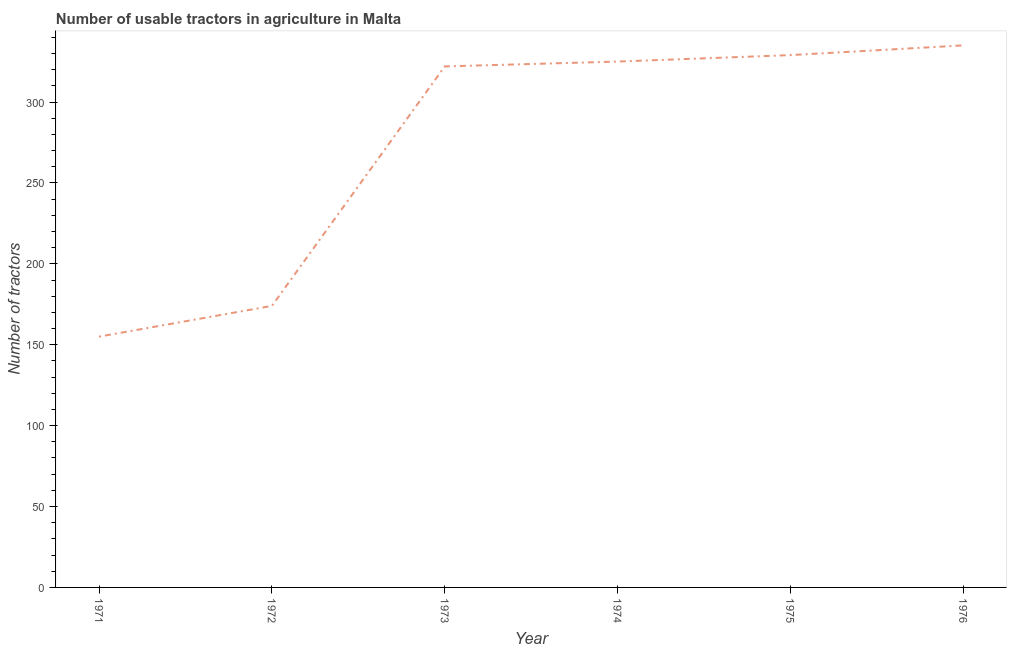What is the number of tractors in 1974?
Keep it short and to the point. 325. Across all years, what is the maximum number of tractors?
Your answer should be compact. 335. Across all years, what is the minimum number of tractors?
Provide a succinct answer. 155. In which year was the number of tractors maximum?
Your answer should be very brief. 1976. What is the sum of the number of tractors?
Make the answer very short. 1640. What is the difference between the number of tractors in 1973 and 1975?
Your response must be concise. -7. What is the average number of tractors per year?
Your answer should be compact. 273.33. What is the median number of tractors?
Offer a terse response. 323.5. In how many years, is the number of tractors greater than 270 ?
Your answer should be compact. 4. What is the ratio of the number of tractors in 1971 to that in 1975?
Give a very brief answer. 0.47. Is the number of tractors in 1971 less than that in 1976?
Keep it short and to the point. Yes. Is the difference between the number of tractors in 1974 and 1975 greater than the difference between any two years?
Your response must be concise. No. What is the difference between the highest and the second highest number of tractors?
Give a very brief answer. 6. Is the sum of the number of tractors in 1974 and 1976 greater than the maximum number of tractors across all years?
Your answer should be very brief. Yes. What is the difference between the highest and the lowest number of tractors?
Make the answer very short. 180. Does the number of tractors monotonically increase over the years?
Ensure brevity in your answer.  Yes. How many years are there in the graph?
Ensure brevity in your answer.  6. What is the difference between two consecutive major ticks on the Y-axis?
Your response must be concise. 50. What is the title of the graph?
Ensure brevity in your answer.  Number of usable tractors in agriculture in Malta. What is the label or title of the X-axis?
Your response must be concise. Year. What is the label or title of the Y-axis?
Provide a short and direct response. Number of tractors. What is the Number of tractors in 1971?
Your answer should be very brief. 155. What is the Number of tractors of 1972?
Offer a terse response. 174. What is the Number of tractors in 1973?
Your answer should be very brief. 322. What is the Number of tractors in 1974?
Keep it short and to the point. 325. What is the Number of tractors of 1975?
Keep it short and to the point. 329. What is the Number of tractors in 1976?
Your answer should be compact. 335. What is the difference between the Number of tractors in 1971 and 1973?
Ensure brevity in your answer.  -167. What is the difference between the Number of tractors in 1971 and 1974?
Your answer should be compact. -170. What is the difference between the Number of tractors in 1971 and 1975?
Make the answer very short. -174. What is the difference between the Number of tractors in 1971 and 1976?
Keep it short and to the point. -180. What is the difference between the Number of tractors in 1972 and 1973?
Ensure brevity in your answer.  -148. What is the difference between the Number of tractors in 1972 and 1974?
Provide a short and direct response. -151. What is the difference between the Number of tractors in 1972 and 1975?
Provide a short and direct response. -155. What is the difference between the Number of tractors in 1972 and 1976?
Give a very brief answer. -161. What is the difference between the Number of tractors in 1973 and 1975?
Your answer should be very brief. -7. What is the difference between the Number of tractors in 1973 and 1976?
Offer a terse response. -13. What is the difference between the Number of tractors in 1974 and 1975?
Your answer should be compact. -4. What is the difference between the Number of tractors in 1974 and 1976?
Make the answer very short. -10. What is the ratio of the Number of tractors in 1971 to that in 1972?
Your answer should be very brief. 0.89. What is the ratio of the Number of tractors in 1971 to that in 1973?
Provide a succinct answer. 0.48. What is the ratio of the Number of tractors in 1971 to that in 1974?
Give a very brief answer. 0.48. What is the ratio of the Number of tractors in 1971 to that in 1975?
Your response must be concise. 0.47. What is the ratio of the Number of tractors in 1971 to that in 1976?
Give a very brief answer. 0.46. What is the ratio of the Number of tractors in 1972 to that in 1973?
Ensure brevity in your answer.  0.54. What is the ratio of the Number of tractors in 1972 to that in 1974?
Provide a succinct answer. 0.54. What is the ratio of the Number of tractors in 1972 to that in 1975?
Offer a very short reply. 0.53. What is the ratio of the Number of tractors in 1972 to that in 1976?
Make the answer very short. 0.52. What is the ratio of the Number of tractors in 1973 to that in 1976?
Your response must be concise. 0.96. What is the ratio of the Number of tractors in 1974 to that in 1976?
Ensure brevity in your answer.  0.97. 